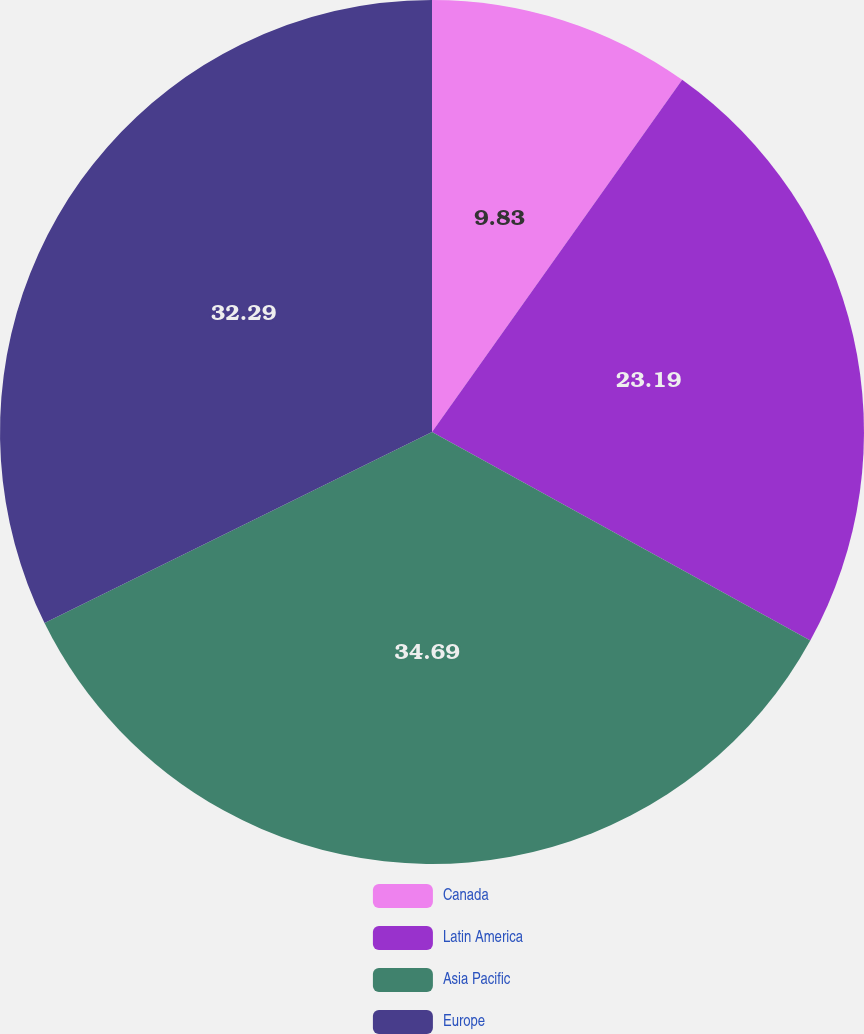Convert chart. <chart><loc_0><loc_0><loc_500><loc_500><pie_chart><fcel>Canada<fcel>Latin America<fcel>Asia Pacific<fcel>Europe<nl><fcel>9.83%<fcel>23.19%<fcel>34.69%<fcel>32.29%<nl></chart> 